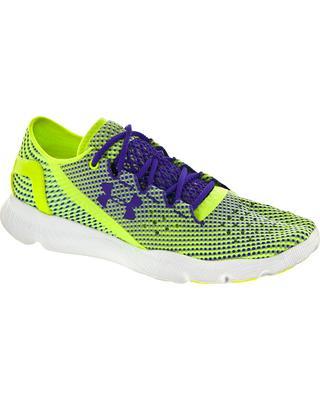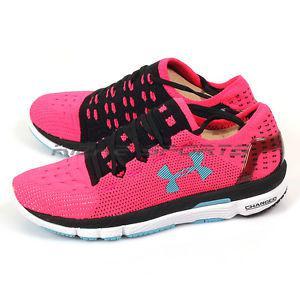The first image is the image on the left, the second image is the image on the right. For the images shown, is this caption "One of the images contains a pink and yellow shoe." true? Answer yes or no. No. The first image is the image on the left, the second image is the image on the right. Considering the images on both sides, is "There are three shoes." valid? Answer yes or no. Yes. 